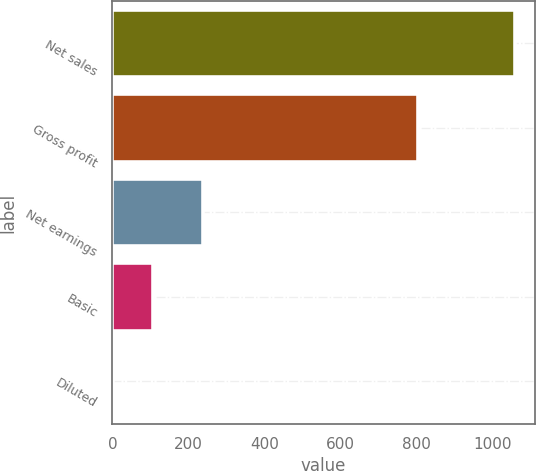Convert chart. <chart><loc_0><loc_0><loc_500><loc_500><bar_chart><fcel>Net sales<fcel>Gross profit<fcel>Net earnings<fcel>Basic<fcel>Diluted<nl><fcel>1059.2<fcel>804.5<fcel>239.3<fcel>106.84<fcel>1.02<nl></chart> 